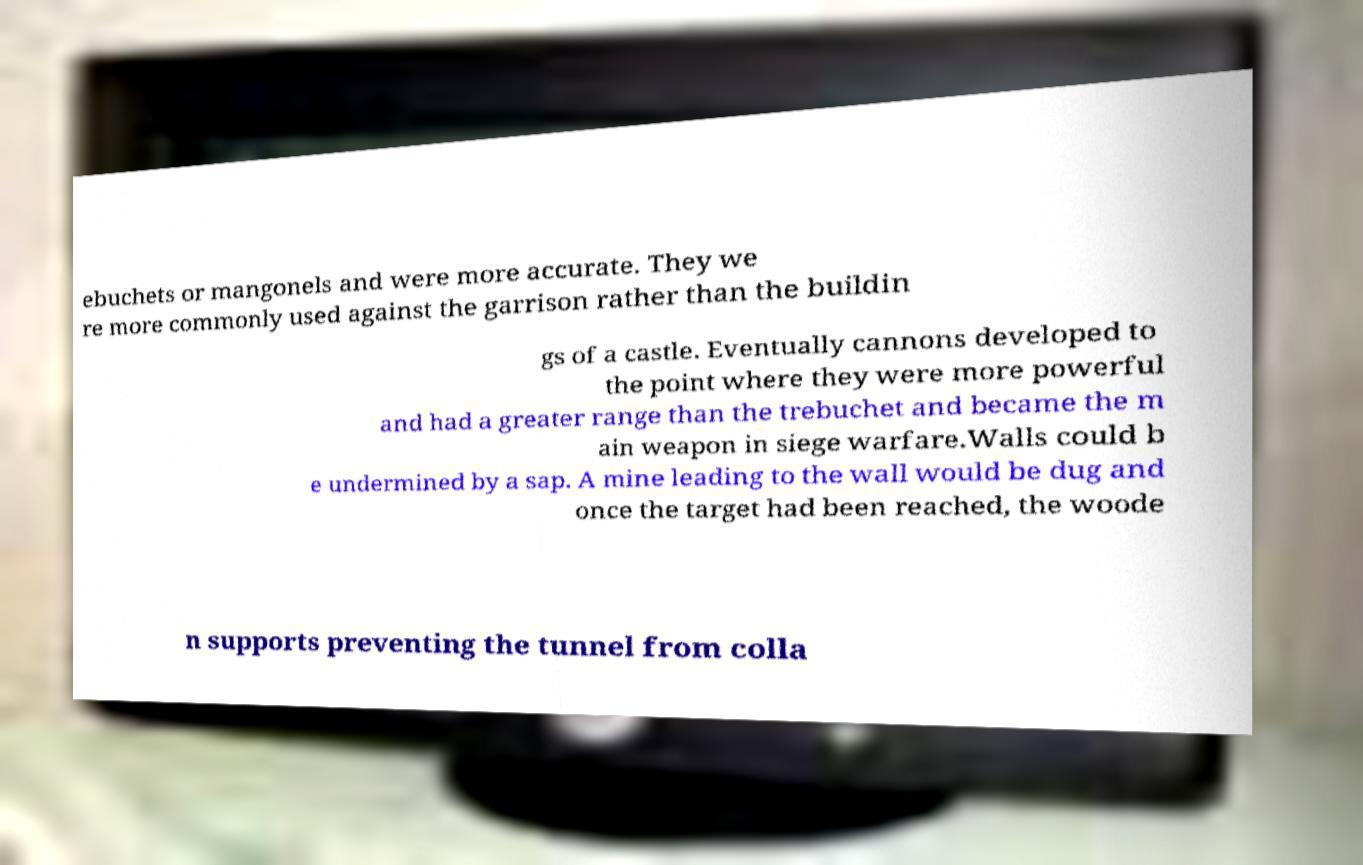Can you accurately transcribe the text from the provided image for me? ebuchets or mangonels and were more accurate. They we re more commonly used against the garrison rather than the buildin gs of a castle. Eventually cannons developed to the point where they were more powerful and had a greater range than the trebuchet and became the m ain weapon in siege warfare.Walls could b e undermined by a sap. A mine leading to the wall would be dug and once the target had been reached, the woode n supports preventing the tunnel from colla 